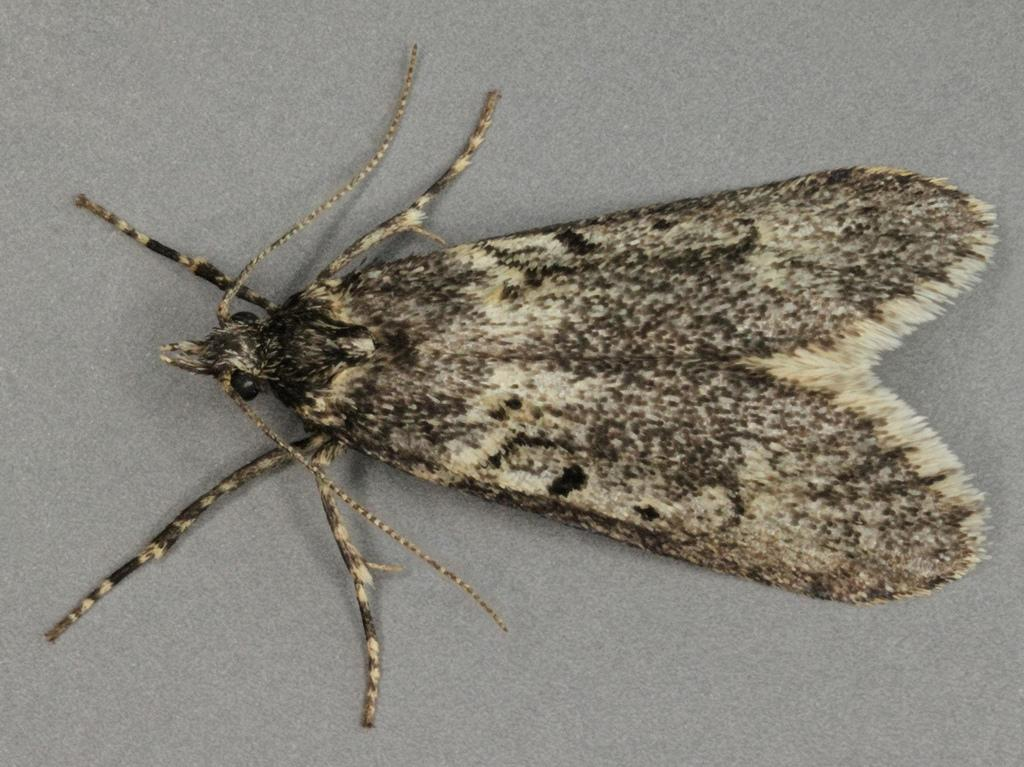What type of creature is in the picture? There is an insect in the picture. What features does the insect have? The insect has wings, legs, and antennae. Where is the insect located in the image? The insect is sitting on a wall. What type of shop can be seen in the image? There is no shop present in the image; it features an insect sitting on a wall. What role does the governor play in the image? There is no governor present in the image; it features an insect sitting on a wall. 